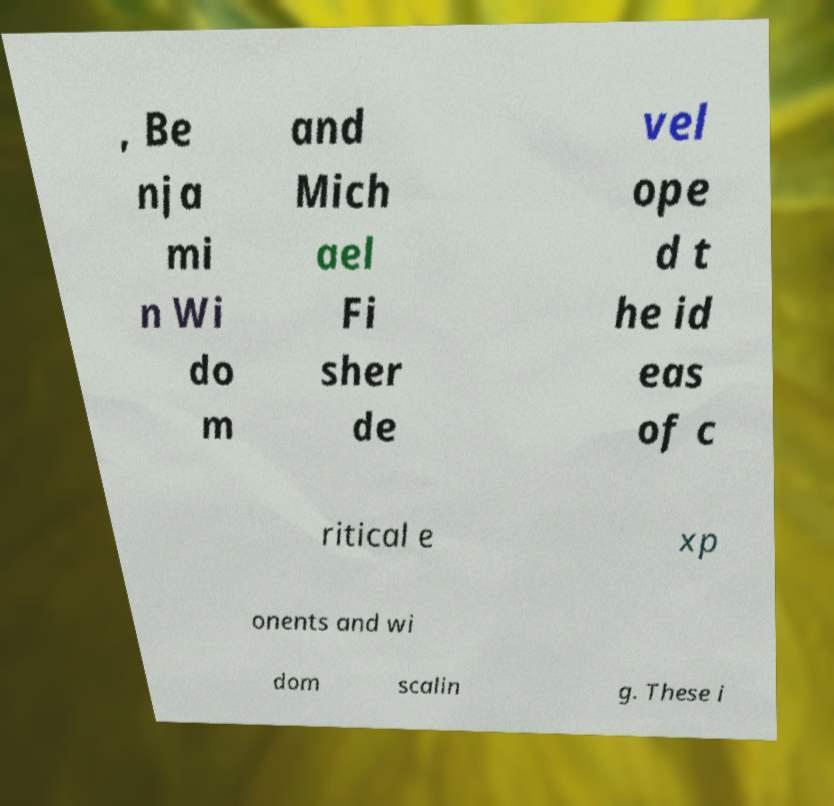What messages or text are displayed in this image? I need them in a readable, typed format. , Be nja mi n Wi do m and Mich ael Fi sher de vel ope d t he id eas of c ritical e xp onents and wi dom scalin g. These i 